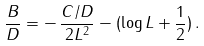<formula> <loc_0><loc_0><loc_500><loc_500>\frac { B } { D } = - \, \frac { C / D } { 2 L ^ { 2 } } - ( \log L + \frac { 1 } { 2 } ) \, .</formula> 